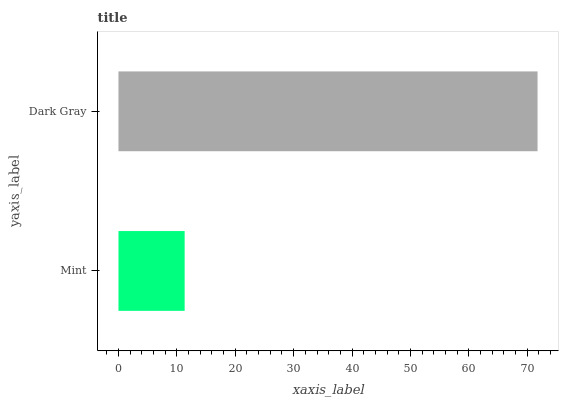Is Mint the minimum?
Answer yes or no. Yes. Is Dark Gray the maximum?
Answer yes or no. Yes. Is Dark Gray the minimum?
Answer yes or no. No. Is Dark Gray greater than Mint?
Answer yes or no. Yes. Is Mint less than Dark Gray?
Answer yes or no. Yes. Is Mint greater than Dark Gray?
Answer yes or no. No. Is Dark Gray less than Mint?
Answer yes or no. No. Is Dark Gray the high median?
Answer yes or no. Yes. Is Mint the low median?
Answer yes or no. Yes. Is Mint the high median?
Answer yes or no. No. Is Dark Gray the low median?
Answer yes or no. No. 